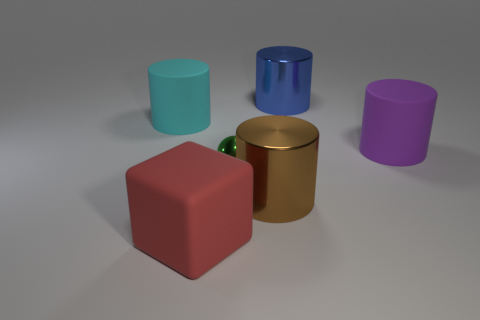Add 1 cyan objects. How many objects exist? 7 Subtract all cylinders. How many objects are left? 2 Add 2 matte cylinders. How many matte cylinders are left? 4 Add 6 large blue cylinders. How many large blue cylinders exist? 7 Subtract 0 cyan spheres. How many objects are left? 6 Subtract all large green matte objects. Subtract all large cyan matte objects. How many objects are left? 5 